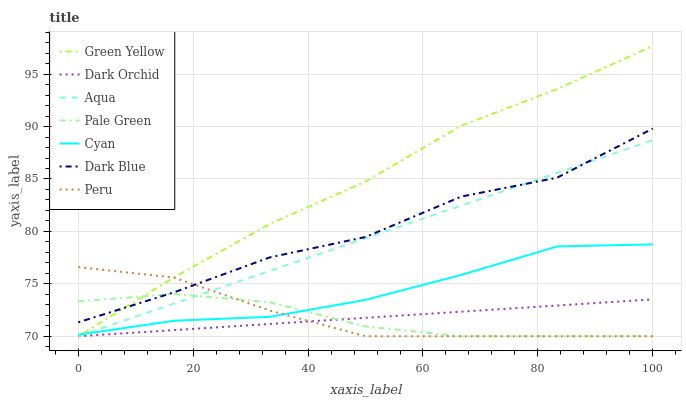Does Pale Green have the minimum area under the curve?
Answer yes or no. Yes. Does Green Yellow have the maximum area under the curve?
Answer yes or no. Yes. Does Dark Orchid have the minimum area under the curve?
Answer yes or no. No. Does Dark Orchid have the maximum area under the curve?
Answer yes or no. No. Is Dark Orchid the smoothest?
Answer yes or no. Yes. Is Dark Blue the roughest?
Answer yes or no. Yes. Is Dark Blue the smoothest?
Answer yes or no. No. Is Dark Orchid the roughest?
Answer yes or no. No. Does Dark Blue have the lowest value?
Answer yes or no. No. Does Dark Blue have the highest value?
Answer yes or no. No. Is Cyan less than Dark Blue?
Answer yes or no. Yes. Is Cyan greater than Dark Orchid?
Answer yes or no. Yes. Does Cyan intersect Dark Blue?
Answer yes or no. No. 